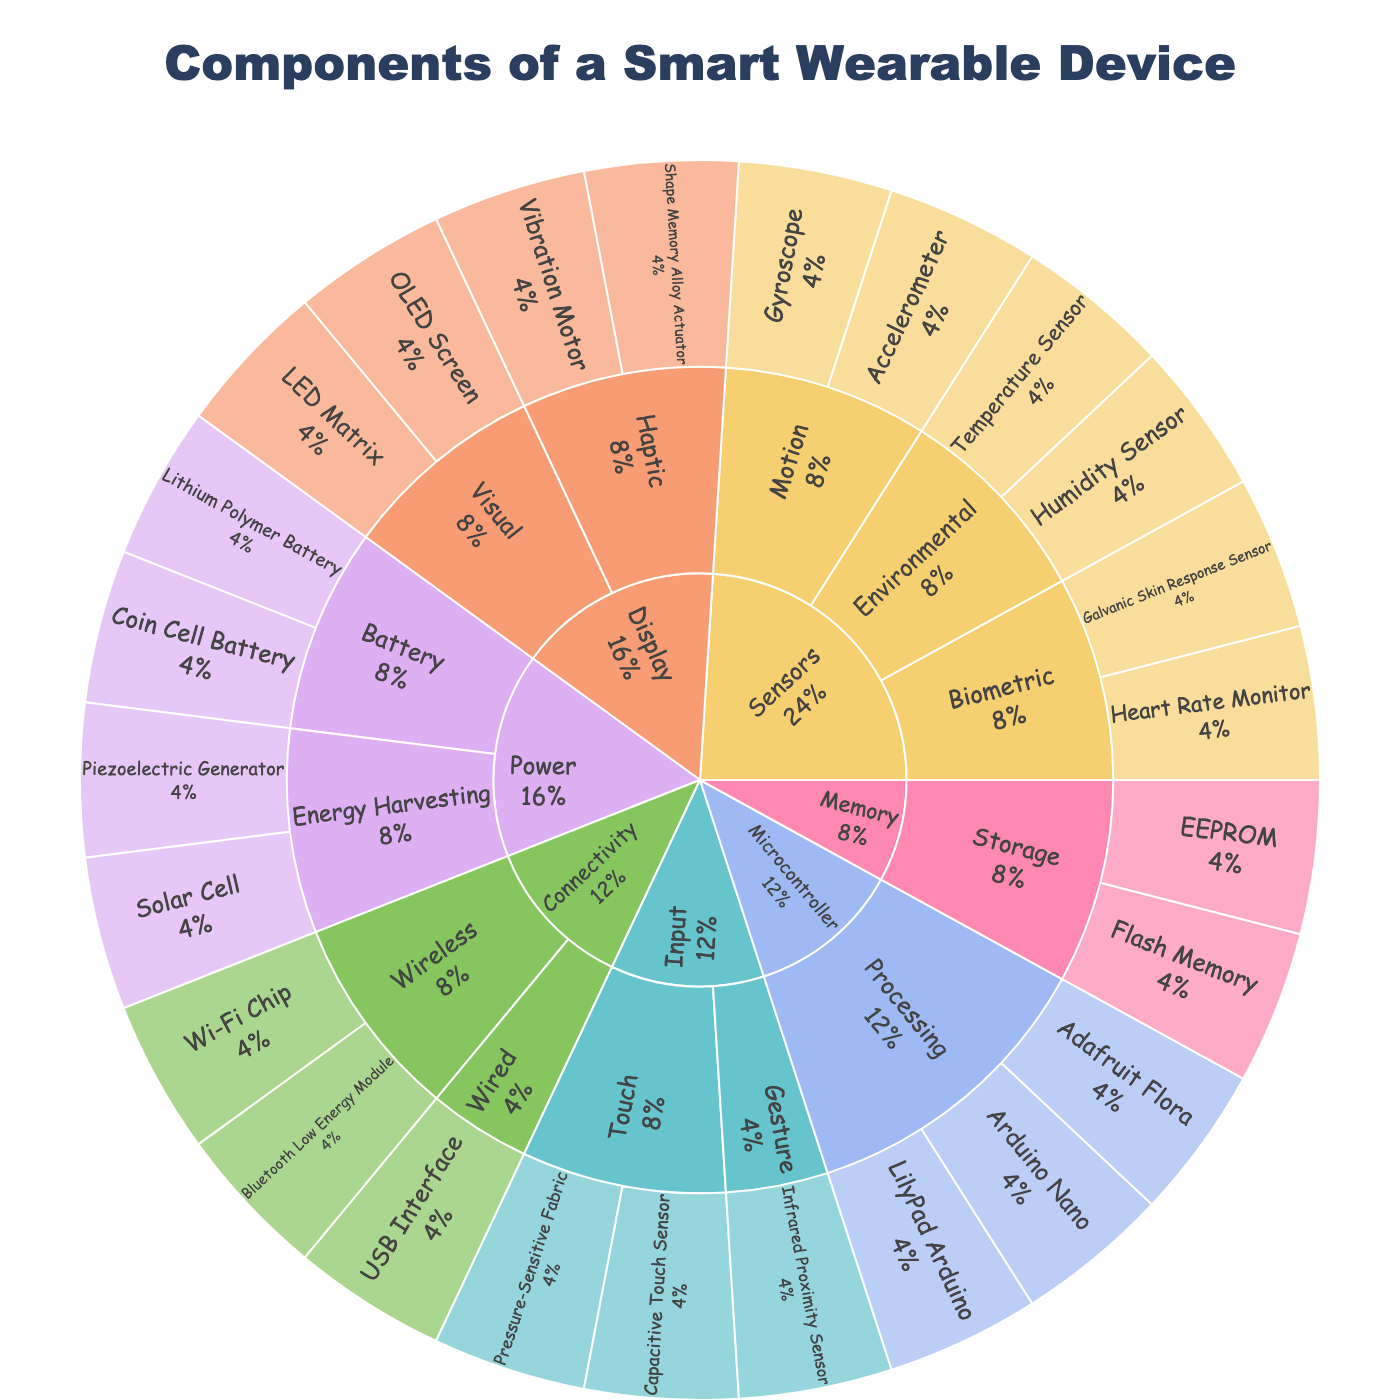What is the main title of the sunburst plot? The main title is typically situated at the top of the chart and prominently displayed.
Answer: Components of a Smart Wearable Device Which category has the most subcategories? Observe the segments branching out directly from the central node and count the number of subcategories for each category. Power, Sensors, and Display all have 2 subcategories, Connectivity, Microcontroller, Input, and Memory have only 1 each.
Answer: Power, Sensors, Display How many components belong to the 'Sensors' category? Follow the path from the 'Sensors' category node and tally the number of leaf nodes (components) directly connected. Sensors have Motion (2), Environmental (2), and Biometric (2) subcategories with a total of 6 components.
Answer: 6 Compare the number of components under 'Power' versus 'Connectivity'. Which category has more and by how many? Count the components under the 'Power' category (Battery - 2, Energy Harvesting - 2) totaling 4 and compare with the 'Connectivity' category (Wireless - 2, Wired - 1) totaling 3. The difference is 1.
Answer: Power has more by 1 Identify the subcategories under the 'Display' category. Trace the branches extending from 'Display' and list the subcategories, which are shown as intermediate nodes.
Answer: Visual, Haptic Which specific component represents the 'Energy Harvesting' subcategory within the 'Power' category? Follow the 'Power' category node to 'Energy Harvesting' and identify the leaf nodes (components) under this subcategory.
Answer: Solar Cell, Piezoelectric Generator What percentage of the total components does 'Microcontroller' represent? Since each category and subcategory is a fraction of the whole, estimate the visual segment size. Microcontroller has 3 out of 24 components making up 12.5% of the total.
Answer: 12.5% Do the number of 'Touch' input components exceed the number of 'Gesture' input components? Compare the components listed under 'Touch' (Capacitive Touch Sensor, Pressure-Sensitive Fabric) with 'Gesture' (Infrared Proximity Sensor). Touch has 2 components while Gesture has 1.
Answer: Yes In terms of component variety, is 'Display' more diverse than 'Memory'? Count the components listed under each subcategory. Display (Visual - 2, Haptic - 2) has 4 components; Memory (Storage - 2) only has 2.
Answer: Yes, Display is more diverse 